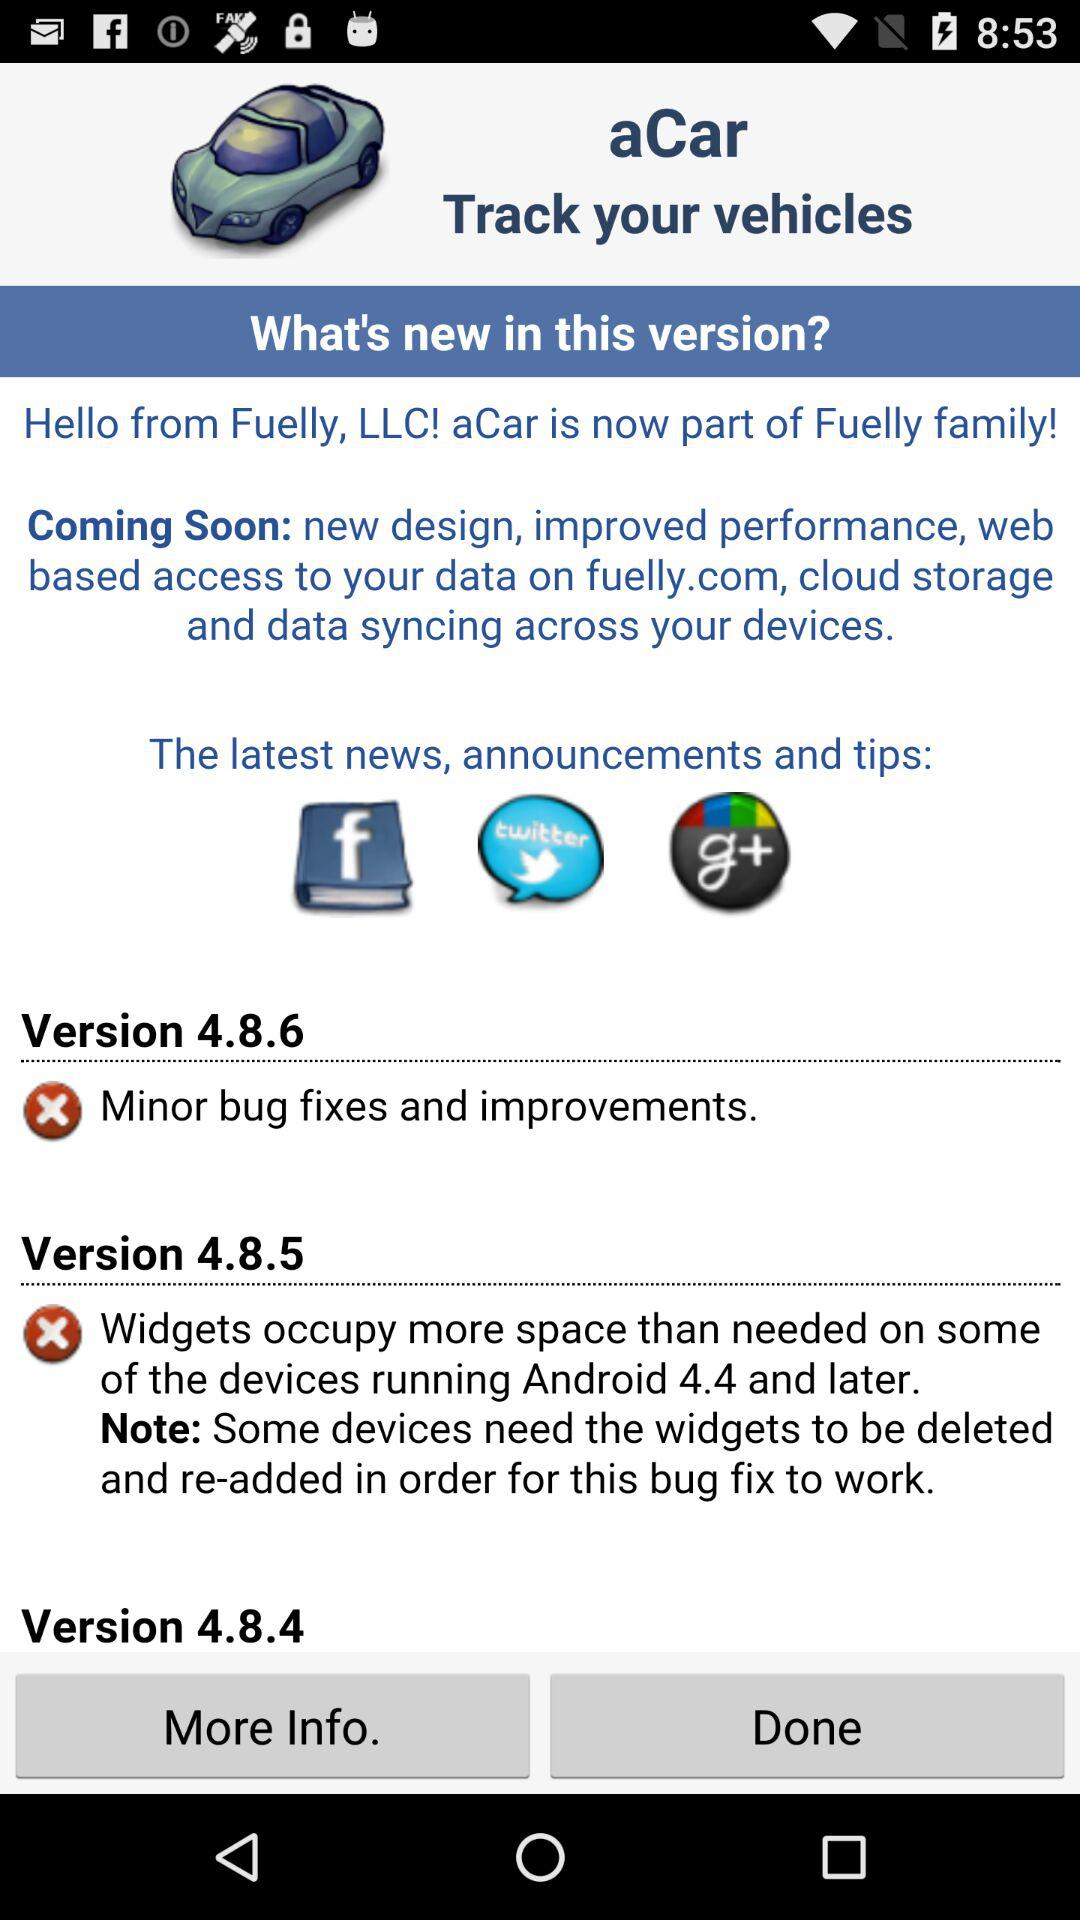What is the app name? The app name is "aCar". 